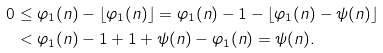Convert formula to latex. <formula><loc_0><loc_0><loc_500><loc_500>0 & \leq \varphi _ { 1 } ( n ) - \lfloor \varphi _ { 1 } ( n ) \rfloor = \varphi _ { 1 } ( n ) - 1 - \lfloor \varphi _ { 1 } ( n ) - \psi ( n ) \rfloor \\ & < \varphi _ { 1 } ( n ) - 1 + 1 + \psi ( n ) - \varphi _ { 1 } ( n ) = \psi ( n ) .</formula> 